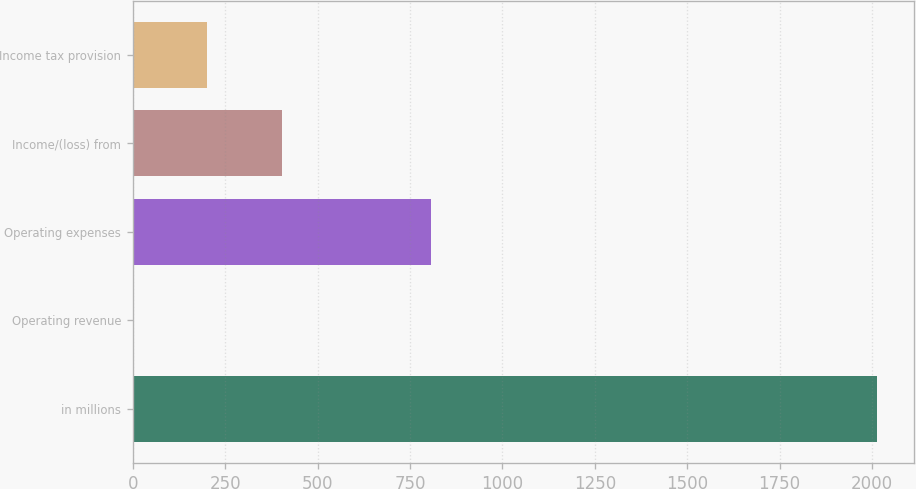<chart> <loc_0><loc_0><loc_500><loc_500><bar_chart><fcel>in millions<fcel>Operating revenue<fcel>Operating expenses<fcel>Income/(loss) from<fcel>Income tax provision<nl><fcel>2014<fcel>0.3<fcel>805.78<fcel>403.04<fcel>201.67<nl></chart> 